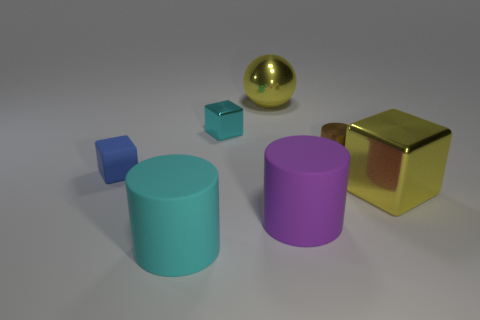Subtract all purple cylinders. How many cylinders are left? 2 Subtract all cyan blocks. How many blocks are left? 2 Subtract all cubes. How many objects are left? 4 Add 1 blue rubber objects. How many objects exist? 8 Subtract 1 cylinders. How many cylinders are left? 2 Add 7 large rubber cylinders. How many large rubber cylinders exist? 9 Subtract 0 red cubes. How many objects are left? 7 Subtract all purple cylinders. Subtract all gray balls. How many cylinders are left? 2 Subtract all purple cubes. How many purple cylinders are left? 1 Subtract all large yellow blocks. Subtract all small shiny objects. How many objects are left? 4 